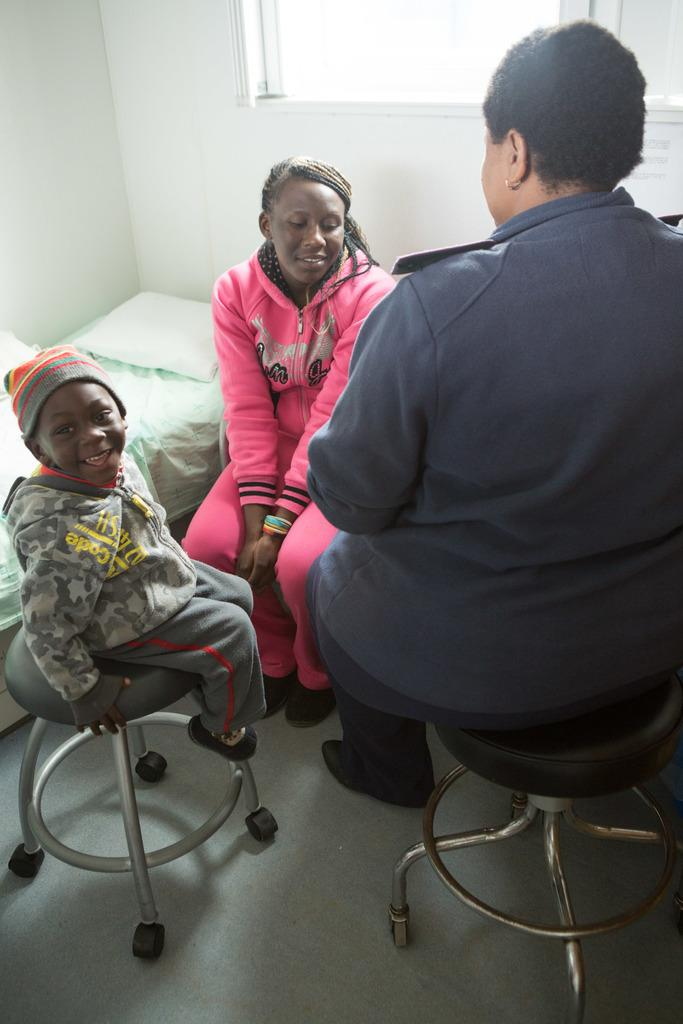How many people are in the image? There are three people in the image. What are the positions of the people in the image? One woman is sitting on a chair, a child is sitting on a stool, and another woman is sitting on a stool. What furniture is present in the image? There is a chair and a stool in the image. What is the background of the image? There is a bed and a white wall in the image. What type of cemetery can be seen in the image? There is no cemetery present in the image; it features three people sitting on furniture in front of a bed and a white wall. What is the temperature in the cellar depicted in the image? There is no cellar present in the image; it features three people sitting on furniture in front of a bed and a white wall. 